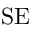Convert formula to latex. <formula><loc_0><loc_0><loc_500><loc_500>S E</formula> 